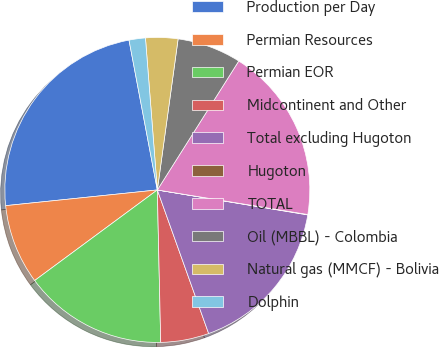Convert chart to OTSL. <chart><loc_0><loc_0><loc_500><loc_500><pie_chart><fcel>Production per Day<fcel>Permian Resources<fcel>Permian EOR<fcel>Midcontinent and Other<fcel>Total excluding Hugoton<fcel>Hugoton<fcel>TOTAL<fcel>Oil (MBBL) - Colombia<fcel>Natural gas (MMCF) - Bolivia<fcel>Dolphin<nl><fcel>23.67%<fcel>8.48%<fcel>15.23%<fcel>5.11%<fcel>16.92%<fcel>0.04%<fcel>18.61%<fcel>6.79%<fcel>3.42%<fcel>1.73%<nl></chart> 